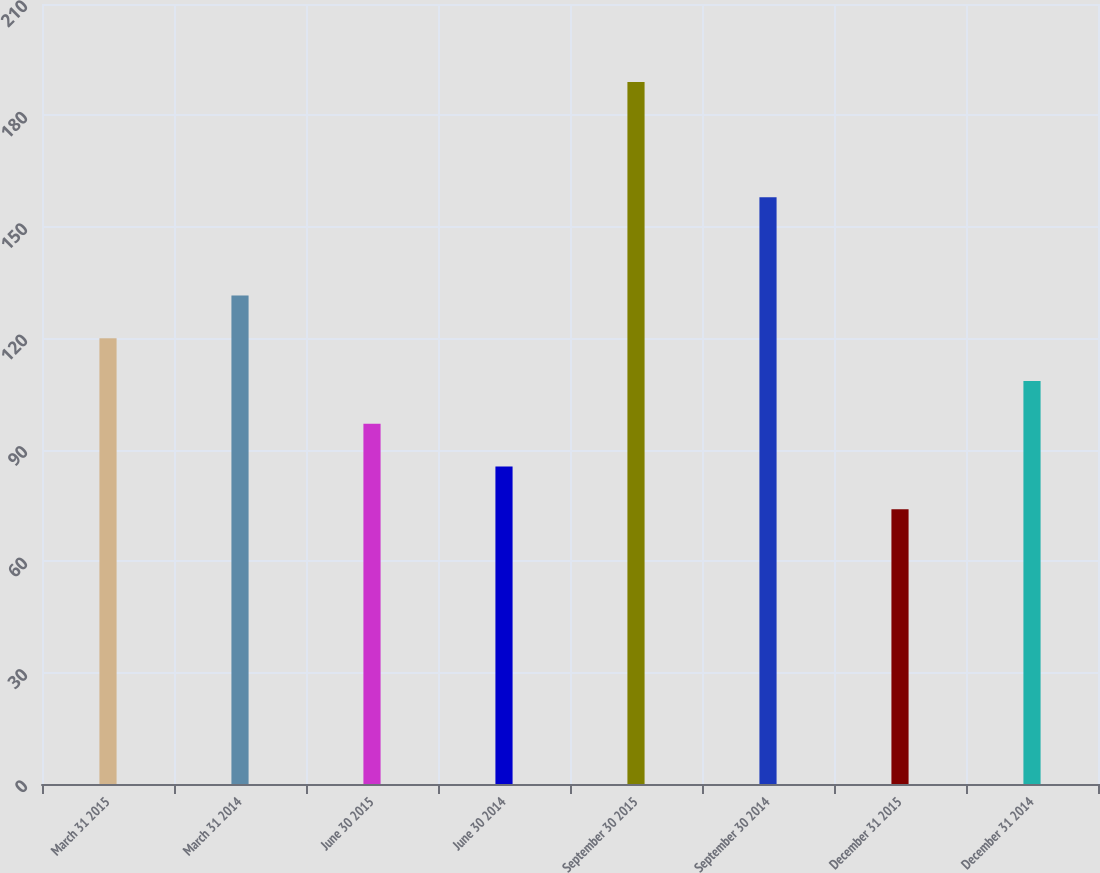Convert chart to OTSL. <chart><loc_0><loc_0><loc_500><loc_500><bar_chart><fcel>March 31 2015<fcel>March 31 2014<fcel>June 30 2015<fcel>June 30 2014<fcel>September 30 2015<fcel>September 30 2014<fcel>December 31 2015<fcel>December 31 2014<nl><fcel>120<fcel>131.5<fcel>97<fcel>85.5<fcel>189<fcel>158<fcel>74<fcel>108.5<nl></chart> 